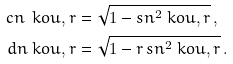Convert formula to latex. <formula><loc_0><loc_0><loc_500><loc_500>c n \ k o { u , r } & = \sqrt { 1 - s n ^ { 2 } \ k o { u , r } } \, , \\ d n \ k o { u , r } & = \sqrt { 1 - r \, s n ^ { 2 } \ k o { u , r } } \, .</formula> 